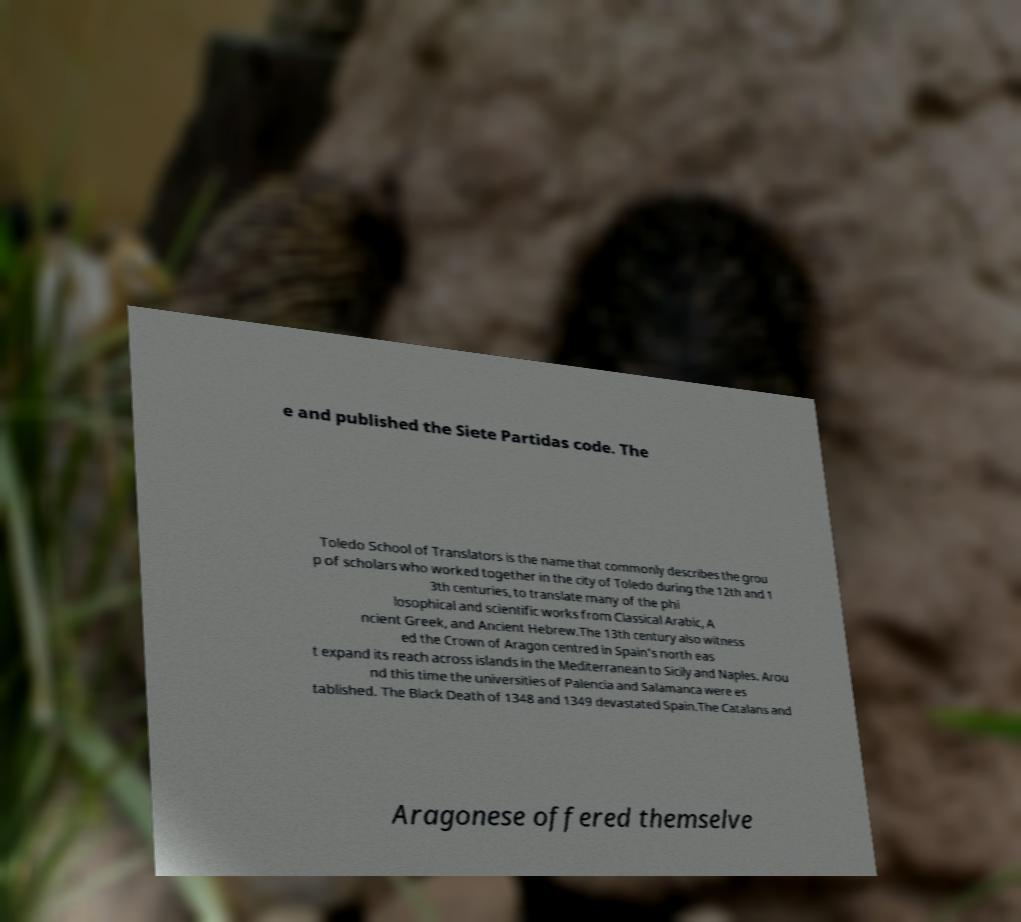Could you assist in decoding the text presented in this image and type it out clearly? e and published the Siete Partidas code. The Toledo School of Translators is the name that commonly describes the grou p of scholars who worked together in the city of Toledo during the 12th and 1 3th centuries, to translate many of the phi losophical and scientific works from Classical Arabic, A ncient Greek, and Ancient Hebrew.The 13th century also witness ed the Crown of Aragon centred in Spain's north eas t expand its reach across islands in the Mediterranean to Sicily and Naples. Arou nd this time the universities of Palencia and Salamanca were es tablished. The Black Death of 1348 and 1349 devastated Spain.The Catalans and Aragonese offered themselve 